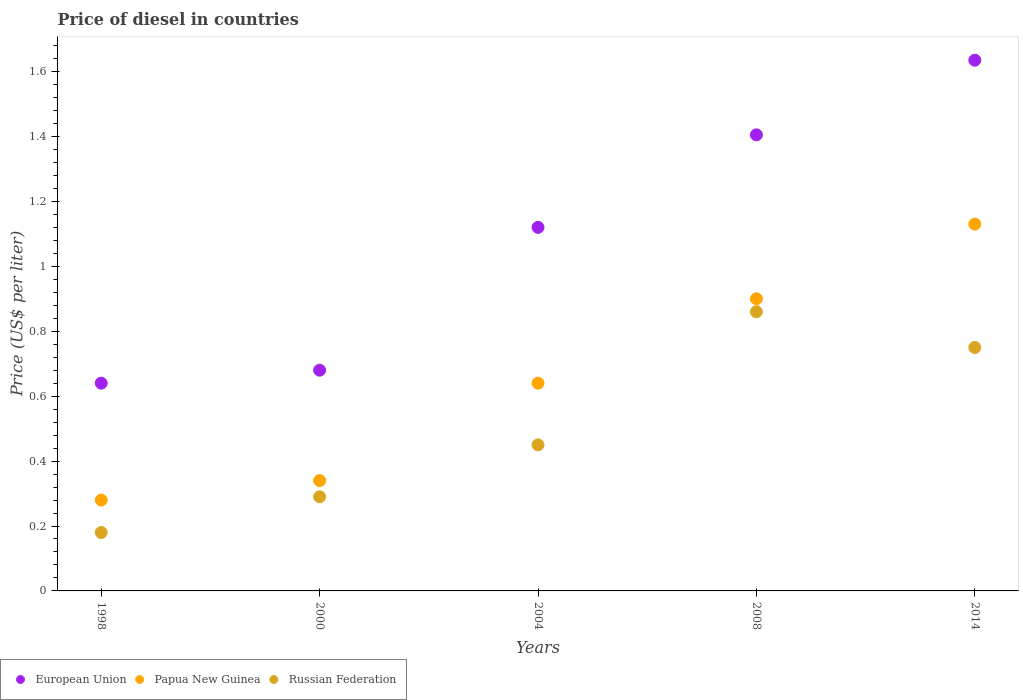Is the number of dotlines equal to the number of legend labels?
Your response must be concise. Yes. What is the price of diesel in Papua New Guinea in 2014?
Provide a succinct answer. 1.13. Across all years, what is the maximum price of diesel in European Union?
Your answer should be very brief. 1.64. Across all years, what is the minimum price of diesel in Papua New Guinea?
Your answer should be very brief. 0.28. In which year was the price of diesel in Russian Federation maximum?
Your answer should be very brief. 2008. What is the total price of diesel in Russian Federation in the graph?
Make the answer very short. 2.53. What is the difference between the price of diesel in European Union in 2008 and that in 2014?
Your answer should be compact. -0.23. What is the difference between the price of diesel in Papua New Guinea in 2004 and the price of diesel in European Union in 2014?
Keep it short and to the point. -0.99. What is the average price of diesel in European Union per year?
Your response must be concise. 1.1. In the year 1998, what is the difference between the price of diesel in Russian Federation and price of diesel in European Union?
Your answer should be compact. -0.46. In how many years, is the price of diesel in European Union greater than 1.2000000000000002 US$?
Keep it short and to the point. 2. What is the ratio of the price of diesel in European Union in 2004 to that in 2014?
Provide a succinct answer. 0.69. Is the difference between the price of diesel in Russian Federation in 1998 and 2004 greater than the difference between the price of diesel in European Union in 1998 and 2004?
Offer a terse response. Yes. What is the difference between the highest and the second highest price of diesel in Papua New Guinea?
Keep it short and to the point. 0.23. What is the difference between the highest and the lowest price of diesel in Papua New Guinea?
Give a very brief answer. 0.85. Is the price of diesel in European Union strictly less than the price of diesel in Papua New Guinea over the years?
Your answer should be compact. No. How many years are there in the graph?
Offer a very short reply. 5. What is the difference between two consecutive major ticks on the Y-axis?
Your answer should be compact. 0.2. Are the values on the major ticks of Y-axis written in scientific E-notation?
Your answer should be very brief. No. Does the graph contain any zero values?
Offer a terse response. No. Does the graph contain grids?
Provide a succinct answer. No. Where does the legend appear in the graph?
Give a very brief answer. Bottom left. How many legend labels are there?
Your answer should be compact. 3. How are the legend labels stacked?
Provide a short and direct response. Horizontal. What is the title of the graph?
Keep it short and to the point. Price of diesel in countries. What is the label or title of the X-axis?
Provide a short and direct response. Years. What is the label or title of the Y-axis?
Provide a short and direct response. Price (US$ per liter). What is the Price (US$ per liter) of European Union in 1998?
Give a very brief answer. 0.64. What is the Price (US$ per liter) in Papua New Guinea in 1998?
Provide a short and direct response. 0.28. What is the Price (US$ per liter) in Russian Federation in 1998?
Provide a succinct answer. 0.18. What is the Price (US$ per liter) of European Union in 2000?
Make the answer very short. 0.68. What is the Price (US$ per liter) in Papua New Guinea in 2000?
Make the answer very short. 0.34. What is the Price (US$ per liter) in Russian Federation in 2000?
Offer a very short reply. 0.29. What is the Price (US$ per liter) of European Union in 2004?
Give a very brief answer. 1.12. What is the Price (US$ per liter) in Papua New Guinea in 2004?
Provide a short and direct response. 0.64. What is the Price (US$ per liter) in Russian Federation in 2004?
Your response must be concise. 0.45. What is the Price (US$ per liter) of European Union in 2008?
Give a very brief answer. 1.41. What is the Price (US$ per liter) of Papua New Guinea in 2008?
Give a very brief answer. 0.9. What is the Price (US$ per liter) in Russian Federation in 2008?
Keep it short and to the point. 0.86. What is the Price (US$ per liter) in European Union in 2014?
Provide a short and direct response. 1.64. What is the Price (US$ per liter) of Papua New Guinea in 2014?
Give a very brief answer. 1.13. What is the Price (US$ per liter) of Russian Federation in 2014?
Make the answer very short. 0.75. Across all years, what is the maximum Price (US$ per liter) of European Union?
Provide a succinct answer. 1.64. Across all years, what is the maximum Price (US$ per liter) of Papua New Guinea?
Your answer should be compact. 1.13. Across all years, what is the maximum Price (US$ per liter) of Russian Federation?
Give a very brief answer. 0.86. Across all years, what is the minimum Price (US$ per liter) of European Union?
Your answer should be compact. 0.64. Across all years, what is the minimum Price (US$ per liter) of Papua New Guinea?
Provide a short and direct response. 0.28. Across all years, what is the minimum Price (US$ per liter) of Russian Federation?
Ensure brevity in your answer.  0.18. What is the total Price (US$ per liter) of European Union in the graph?
Provide a short and direct response. 5.48. What is the total Price (US$ per liter) of Papua New Guinea in the graph?
Make the answer very short. 3.29. What is the total Price (US$ per liter) in Russian Federation in the graph?
Your answer should be compact. 2.53. What is the difference between the Price (US$ per liter) in European Union in 1998 and that in 2000?
Provide a short and direct response. -0.04. What is the difference between the Price (US$ per liter) in Papua New Guinea in 1998 and that in 2000?
Provide a succinct answer. -0.06. What is the difference between the Price (US$ per liter) in Russian Federation in 1998 and that in 2000?
Keep it short and to the point. -0.11. What is the difference between the Price (US$ per liter) in European Union in 1998 and that in 2004?
Offer a terse response. -0.48. What is the difference between the Price (US$ per liter) in Papua New Guinea in 1998 and that in 2004?
Provide a succinct answer. -0.36. What is the difference between the Price (US$ per liter) in Russian Federation in 1998 and that in 2004?
Offer a very short reply. -0.27. What is the difference between the Price (US$ per liter) in European Union in 1998 and that in 2008?
Keep it short and to the point. -0.77. What is the difference between the Price (US$ per liter) of Papua New Guinea in 1998 and that in 2008?
Make the answer very short. -0.62. What is the difference between the Price (US$ per liter) in Russian Federation in 1998 and that in 2008?
Offer a terse response. -0.68. What is the difference between the Price (US$ per liter) of European Union in 1998 and that in 2014?
Provide a succinct answer. -0.99. What is the difference between the Price (US$ per liter) in Papua New Guinea in 1998 and that in 2014?
Your answer should be compact. -0.85. What is the difference between the Price (US$ per liter) of Russian Federation in 1998 and that in 2014?
Your response must be concise. -0.57. What is the difference between the Price (US$ per liter) in European Union in 2000 and that in 2004?
Keep it short and to the point. -0.44. What is the difference between the Price (US$ per liter) in Russian Federation in 2000 and that in 2004?
Keep it short and to the point. -0.16. What is the difference between the Price (US$ per liter) in European Union in 2000 and that in 2008?
Offer a very short reply. -0.72. What is the difference between the Price (US$ per liter) in Papua New Guinea in 2000 and that in 2008?
Ensure brevity in your answer.  -0.56. What is the difference between the Price (US$ per liter) of Russian Federation in 2000 and that in 2008?
Your answer should be very brief. -0.57. What is the difference between the Price (US$ per liter) of European Union in 2000 and that in 2014?
Your response must be concise. -0.95. What is the difference between the Price (US$ per liter) in Papua New Guinea in 2000 and that in 2014?
Make the answer very short. -0.79. What is the difference between the Price (US$ per liter) of Russian Federation in 2000 and that in 2014?
Offer a very short reply. -0.46. What is the difference between the Price (US$ per liter) of European Union in 2004 and that in 2008?
Give a very brief answer. -0.28. What is the difference between the Price (US$ per liter) of Papua New Guinea in 2004 and that in 2008?
Make the answer very short. -0.26. What is the difference between the Price (US$ per liter) of Russian Federation in 2004 and that in 2008?
Offer a very short reply. -0.41. What is the difference between the Price (US$ per liter) in European Union in 2004 and that in 2014?
Offer a very short reply. -0.52. What is the difference between the Price (US$ per liter) in Papua New Guinea in 2004 and that in 2014?
Your answer should be compact. -0.49. What is the difference between the Price (US$ per liter) of European Union in 2008 and that in 2014?
Your answer should be very brief. -0.23. What is the difference between the Price (US$ per liter) of Papua New Guinea in 2008 and that in 2014?
Offer a very short reply. -0.23. What is the difference between the Price (US$ per liter) of Russian Federation in 2008 and that in 2014?
Provide a short and direct response. 0.11. What is the difference between the Price (US$ per liter) of European Union in 1998 and the Price (US$ per liter) of Russian Federation in 2000?
Offer a very short reply. 0.35. What is the difference between the Price (US$ per liter) of Papua New Guinea in 1998 and the Price (US$ per liter) of Russian Federation in 2000?
Ensure brevity in your answer.  -0.01. What is the difference between the Price (US$ per liter) of European Union in 1998 and the Price (US$ per liter) of Russian Federation in 2004?
Your answer should be compact. 0.19. What is the difference between the Price (US$ per liter) in Papua New Guinea in 1998 and the Price (US$ per liter) in Russian Federation in 2004?
Keep it short and to the point. -0.17. What is the difference between the Price (US$ per liter) of European Union in 1998 and the Price (US$ per liter) of Papua New Guinea in 2008?
Your response must be concise. -0.26. What is the difference between the Price (US$ per liter) of European Union in 1998 and the Price (US$ per liter) of Russian Federation in 2008?
Provide a short and direct response. -0.22. What is the difference between the Price (US$ per liter) of Papua New Guinea in 1998 and the Price (US$ per liter) of Russian Federation in 2008?
Give a very brief answer. -0.58. What is the difference between the Price (US$ per liter) of European Union in 1998 and the Price (US$ per liter) of Papua New Guinea in 2014?
Your answer should be very brief. -0.49. What is the difference between the Price (US$ per liter) of European Union in 1998 and the Price (US$ per liter) of Russian Federation in 2014?
Offer a very short reply. -0.11. What is the difference between the Price (US$ per liter) in Papua New Guinea in 1998 and the Price (US$ per liter) in Russian Federation in 2014?
Offer a very short reply. -0.47. What is the difference between the Price (US$ per liter) of European Union in 2000 and the Price (US$ per liter) of Papua New Guinea in 2004?
Your answer should be compact. 0.04. What is the difference between the Price (US$ per liter) in European Union in 2000 and the Price (US$ per liter) in Russian Federation in 2004?
Provide a succinct answer. 0.23. What is the difference between the Price (US$ per liter) of Papua New Guinea in 2000 and the Price (US$ per liter) of Russian Federation in 2004?
Your answer should be very brief. -0.11. What is the difference between the Price (US$ per liter) in European Union in 2000 and the Price (US$ per liter) in Papua New Guinea in 2008?
Make the answer very short. -0.22. What is the difference between the Price (US$ per liter) in European Union in 2000 and the Price (US$ per liter) in Russian Federation in 2008?
Offer a very short reply. -0.18. What is the difference between the Price (US$ per liter) of Papua New Guinea in 2000 and the Price (US$ per liter) of Russian Federation in 2008?
Offer a very short reply. -0.52. What is the difference between the Price (US$ per liter) of European Union in 2000 and the Price (US$ per liter) of Papua New Guinea in 2014?
Provide a short and direct response. -0.45. What is the difference between the Price (US$ per liter) of European Union in 2000 and the Price (US$ per liter) of Russian Federation in 2014?
Provide a succinct answer. -0.07. What is the difference between the Price (US$ per liter) in Papua New Guinea in 2000 and the Price (US$ per liter) in Russian Federation in 2014?
Provide a short and direct response. -0.41. What is the difference between the Price (US$ per liter) of European Union in 2004 and the Price (US$ per liter) of Papua New Guinea in 2008?
Your answer should be compact. 0.22. What is the difference between the Price (US$ per liter) in European Union in 2004 and the Price (US$ per liter) in Russian Federation in 2008?
Provide a short and direct response. 0.26. What is the difference between the Price (US$ per liter) in Papua New Guinea in 2004 and the Price (US$ per liter) in Russian Federation in 2008?
Your answer should be compact. -0.22. What is the difference between the Price (US$ per liter) of European Union in 2004 and the Price (US$ per liter) of Papua New Guinea in 2014?
Your response must be concise. -0.01. What is the difference between the Price (US$ per liter) of European Union in 2004 and the Price (US$ per liter) of Russian Federation in 2014?
Your answer should be very brief. 0.37. What is the difference between the Price (US$ per liter) in Papua New Guinea in 2004 and the Price (US$ per liter) in Russian Federation in 2014?
Ensure brevity in your answer.  -0.11. What is the difference between the Price (US$ per liter) in European Union in 2008 and the Price (US$ per liter) in Papua New Guinea in 2014?
Your response must be concise. 0.28. What is the difference between the Price (US$ per liter) in European Union in 2008 and the Price (US$ per liter) in Russian Federation in 2014?
Offer a very short reply. 0.66. What is the difference between the Price (US$ per liter) in Papua New Guinea in 2008 and the Price (US$ per liter) in Russian Federation in 2014?
Provide a succinct answer. 0.15. What is the average Price (US$ per liter) in European Union per year?
Offer a very short reply. 1.1. What is the average Price (US$ per liter) of Papua New Guinea per year?
Your answer should be very brief. 0.66. What is the average Price (US$ per liter) of Russian Federation per year?
Your answer should be compact. 0.51. In the year 1998, what is the difference between the Price (US$ per liter) in European Union and Price (US$ per liter) in Papua New Guinea?
Give a very brief answer. 0.36. In the year 1998, what is the difference between the Price (US$ per liter) of European Union and Price (US$ per liter) of Russian Federation?
Your answer should be compact. 0.46. In the year 2000, what is the difference between the Price (US$ per liter) of European Union and Price (US$ per liter) of Papua New Guinea?
Your answer should be very brief. 0.34. In the year 2000, what is the difference between the Price (US$ per liter) of European Union and Price (US$ per liter) of Russian Federation?
Your response must be concise. 0.39. In the year 2004, what is the difference between the Price (US$ per liter) in European Union and Price (US$ per liter) in Papua New Guinea?
Provide a succinct answer. 0.48. In the year 2004, what is the difference between the Price (US$ per liter) of European Union and Price (US$ per liter) of Russian Federation?
Your response must be concise. 0.67. In the year 2004, what is the difference between the Price (US$ per liter) of Papua New Guinea and Price (US$ per liter) of Russian Federation?
Provide a succinct answer. 0.19. In the year 2008, what is the difference between the Price (US$ per liter) of European Union and Price (US$ per liter) of Papua New Guinea?
Your response must be concise. 0.51. In the year 2008, what is the difference between the Price (US$ per liter) in European Union and Price (US$ per liter) in Russian Federation?
Keep it short and to the point. 0.55. In the year 2014, what is the difference between the Price (US$ per liter) of European Union and Price (US$ per liter) of Papua New Guinea?
Your response must be concise. 0.51. In the year 2014, what is the difference between the Price (US$ per liter) of European Union and Price (US$ per liter) of Russian Federation?
Give a very brief answer. 0.89. In the year 2014, what is the difference between the Price (US$ per liter) in Papua New Guinea and Price (US$ per liter) in Russian Federation?
Provide a succinct answer. 0.38. What is the ratio of the Price (US$ per liter) in European Union in 1998 to that in 2000?
Ensure brevity in your answer.  0.94. What is the ratio of the Price (US$ per liter) of Papua New Guinea in 1998 to that in 2000?
Your answer should be compact. 0.82. What is the ratio of the Price (US$ per liter) in Russian Federation in 1998 to that in 2000?
Provide a succinct answer. 0.62. What is the ratio of the Price (US$ per liter) of European Union in 1998 to that in 2004?
Your response must be concise. 0.57. What is the ratio of the Price (US$ per liter) of Papua New Guinea in 1998 to that in 2004?
Keep it short and to the point. 0.44. What is the ratio of the Price (US$ per liter) of European Union in 1998 to that in 2008?
Offer a terse response. 0.46. What is the ratio of the Price (US$ per liter) in Papua New Guinea in 1998 to that in 2008?
Make the answer very short. 0.31. What is the ratio of the Price (US$ per liter) in Russian Federation in 1998 to that in 2008?
Make the answer very short. 0.21. What is the ratio of the Price (US$ per liter) of European Union in 1998 to that in 2014?
Your answer should be compact. 0.39. What is the ratio of the Price (US$ per liter) in Papua New Guinea in 1998 to that in 2014?
Provide a succinct answer. 0.25. What is the ratio of the Price (US$ per liter) of Russian Federation in 1998 to that in 2014?
Your response must be concise. 0.24. What is the ratio of the Price (US$ per liter) in European Union in 2000 to that in 2004?
Offer a terse response. 0.61. What is the ratio of the Price (US$ per liter) of Papua New Guinea in 2000 to that in 2004?
Make the answer very short. 0.53. What is the ratio of the Price (US$ per liter) of Russian Federation in 2000 to that in 2004?
Give a very brief answer. 0.64. What is the ratio of the Price (US$ per liter) in European Union in 2000 to that in 2008?
Your answer should be compact. 0.48. What is the ratio of the Price (US$ per liter) in Papua New Guinea in 2000 to that in 2008?
Keep it short and to the point. 0.38. What is the ratio of the Price (US$ per liter) in Russian Federation in 2000 to that in 2008?
Give a very brief answer. 0.34. What is the ratio of the Price (US$ per liter) in European Union in 2000 to that in 2014?
Ensure brevity in your answer.  0.42. What is the ratio of the Price (US$ per liter) in Papua New Guinea in 2000 to that in 2014?
Your answer should be very brief. 0.3. What is the ratio of the Price (US$ per liter) in Russian Federation in 2000 to that in 2014?
Your response must be concise. 0.39. What is the ratio of the Price (US$ per liter) of European Union in 2004 to that in 2008?
Your answer should be compact. 0.8. What is the ratio of the Price (US$ per liter) in Papua New Guinea in 2004 to that in 2008?
Your response must be concise. 0.71. What is the ratio of the Price (US$ per liter) in Russian Federation in 2004 to that in 2008?
Provide a succinct answer. 0.52. What is the ratio of the Price (US$ per liter) of European Union in 2004 to that in 2014?
Your answer should be compact. 0.69. What is the ratio of the Price (US$ per liter) in Papua New Guinea in 2004 to that in 2014?
Ensure brevity in your answer.  0.57. What is the ratio of the Price (US$ per liter) of Russian Federation in 2004 to that in 2014?
Offer a very short reply. 0.6. What is the ratio of the Price (US$ per liter) of European Union in 2008 to that in 2014?
Ensure brevity in your answer.  0.86. What is the ratio of the Price (US$ per liter) in Papua New Guinea in 2008 to that in 2014?
Your response must be concise. 0.8. What is the ratio of the Price (US$ per liter) in Russian Federation in 2008 to that in 2014?
Provide a short and direct response. 1.15. What is the difference between the highest and the second highest Price (US$ per liter) of European Union?
Offer a terse response. 0.23. What is the difference between the highest and the second highest Price (US$ per liter) in Papua New Guinea?
Your answer should be compact. 0.23. What is the difference between the highest and the second highest Price (US$ per liter) of Russian Federation?
Offer a terse response. 0.11. What is the difference between the highest and the lowest Price (US$ per liter) of European Union?
Your answer should be compact. 0.99. What is the difference between the highest and the lowest Price (US$ per liter) of Papua New Guinea?
Your response must be concise. 0.85. What is the difference between the highest and the lowest Price (US$ per liter) in Russian Federation?
Keep it short and to the point. 0.68. 